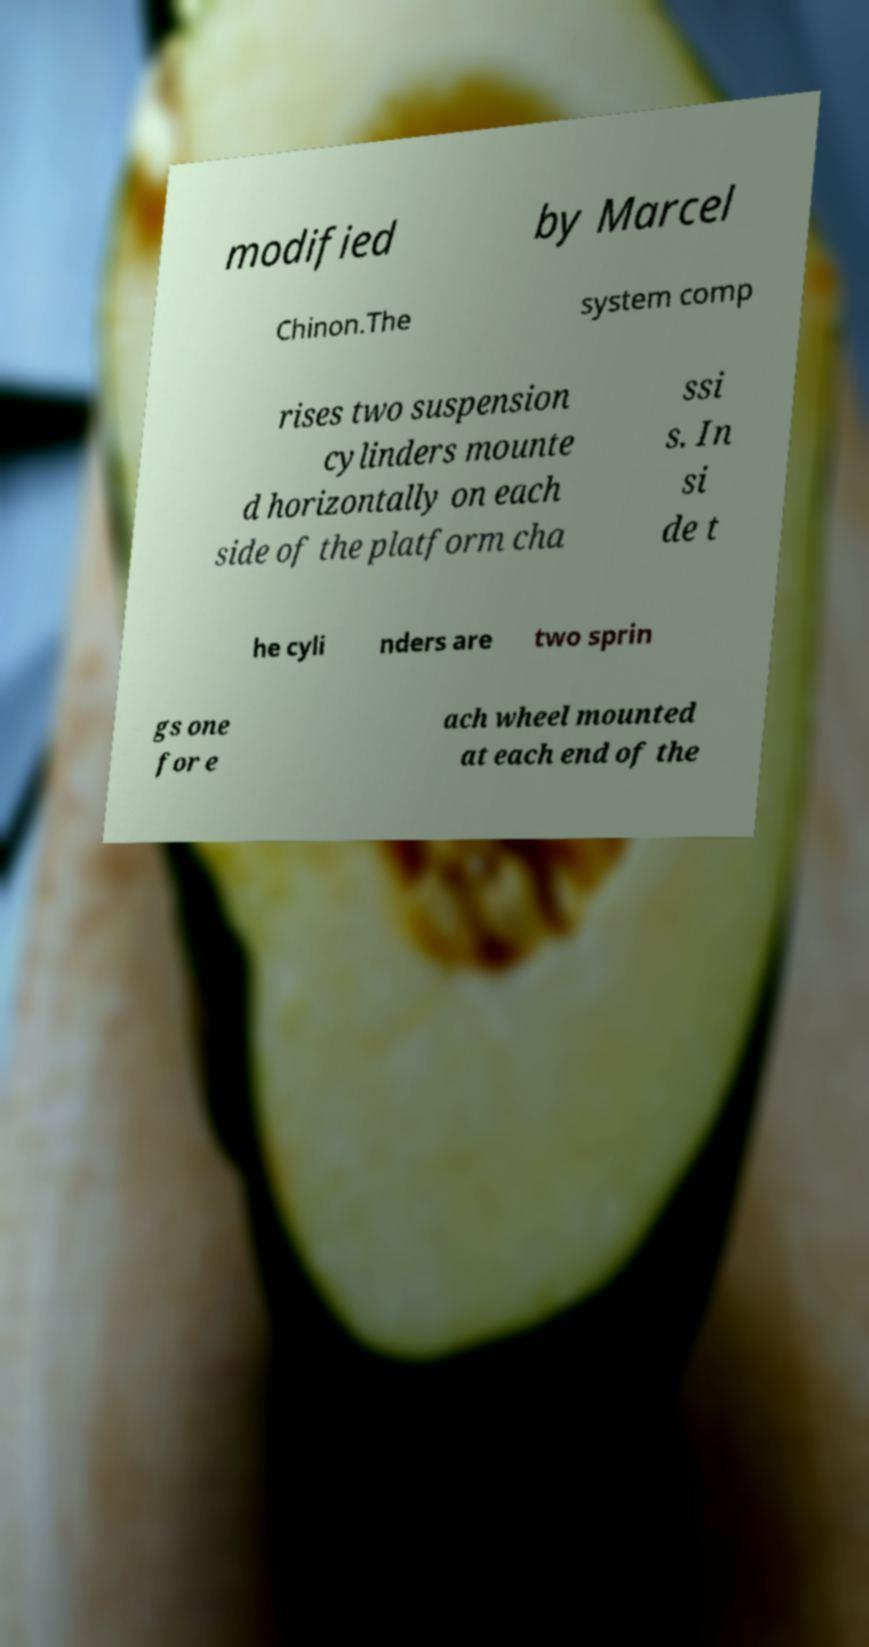I need the written content from this picture converted into text. Can you do that? modified by Marcel Chinon.The system comp rises two suspension cylinders mounte d horizontally on each side of the platform cha ssi s. In si de t he cyli nders are two sprin gs one for e ach wheel mounted at each end of the 